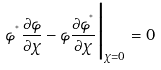<formula> <loc_0><loc_0><loc_500><loc_500>\varphi ^ { ^ { * } } \frac { \partial \varphi } { \partial \chi } - \varphi \frac { \partial \varphi ^ { ^ { * } } } { \partial \chi } \Big | _ { \chi = 0 } = 0</formula> 